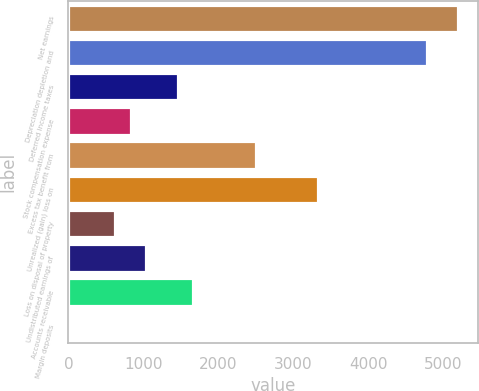<chart> <loc_0><loc_0><loc_500><loc_500><bar_chart><fcel>Net earnings<fcel>Depreciation depletion and<fcel>Deferred income taxes<fcel>Stock compensation expense<fcel>Excess tax benefit from<fcel>Unrealized (gain) loss on<fcel>Loss on disposal of property<fcel>Undistributed earnings of<fcel>Accounts receivable<fcel>Margin deposits<nl><fcel>5195.15<fcel>4779.65<fcel>1455.65<fcel>832.4<fcel>2494.4<fcel>3325.4<fcel>624.65<fcel>1040.15<fcel>1663.4<fcel>1.4<nl></chart> 